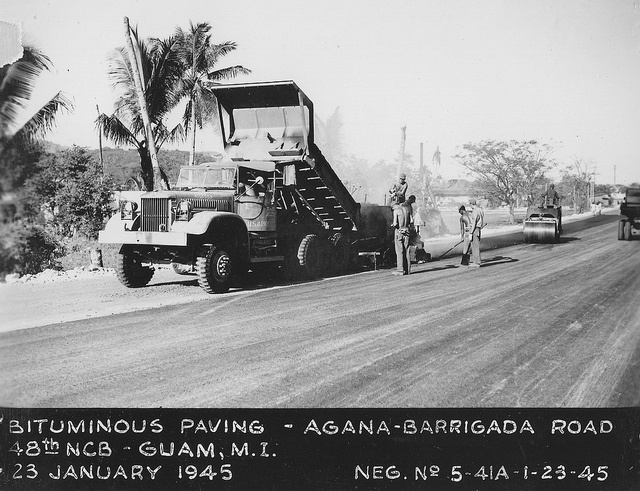Describe the objects in this image and their specific colors. I can see truck in lightgray, black, darkgray, and gray tones, people in lightgray, darkgray, black, and gray tones, people in lightgray, darkgray, gray, and black tones, people in lightgray, darkgray, gray, and black tones, and people in lightgray, darkgray, gray, and black tones in this image. 